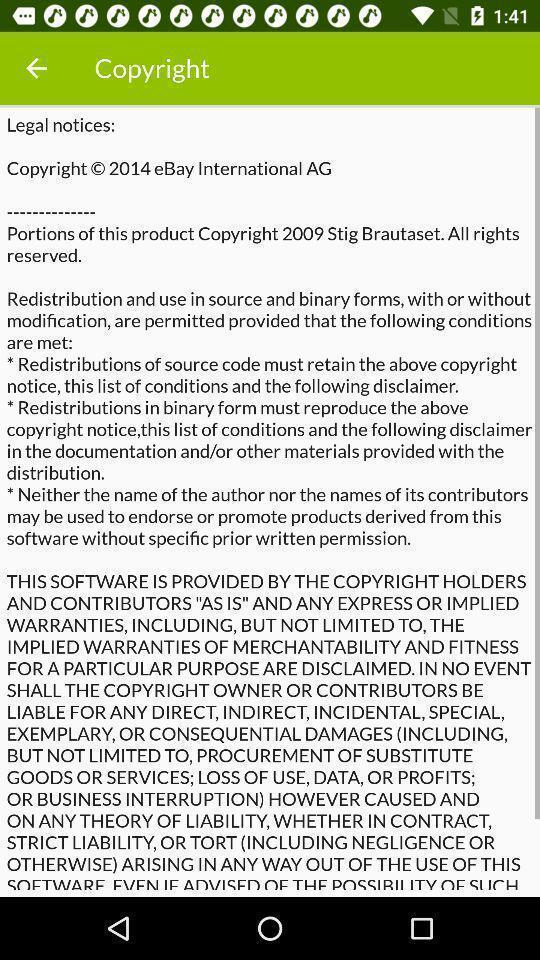Give me a summary of this screen capture. Page displaying the detailed information of copyright for an app. 